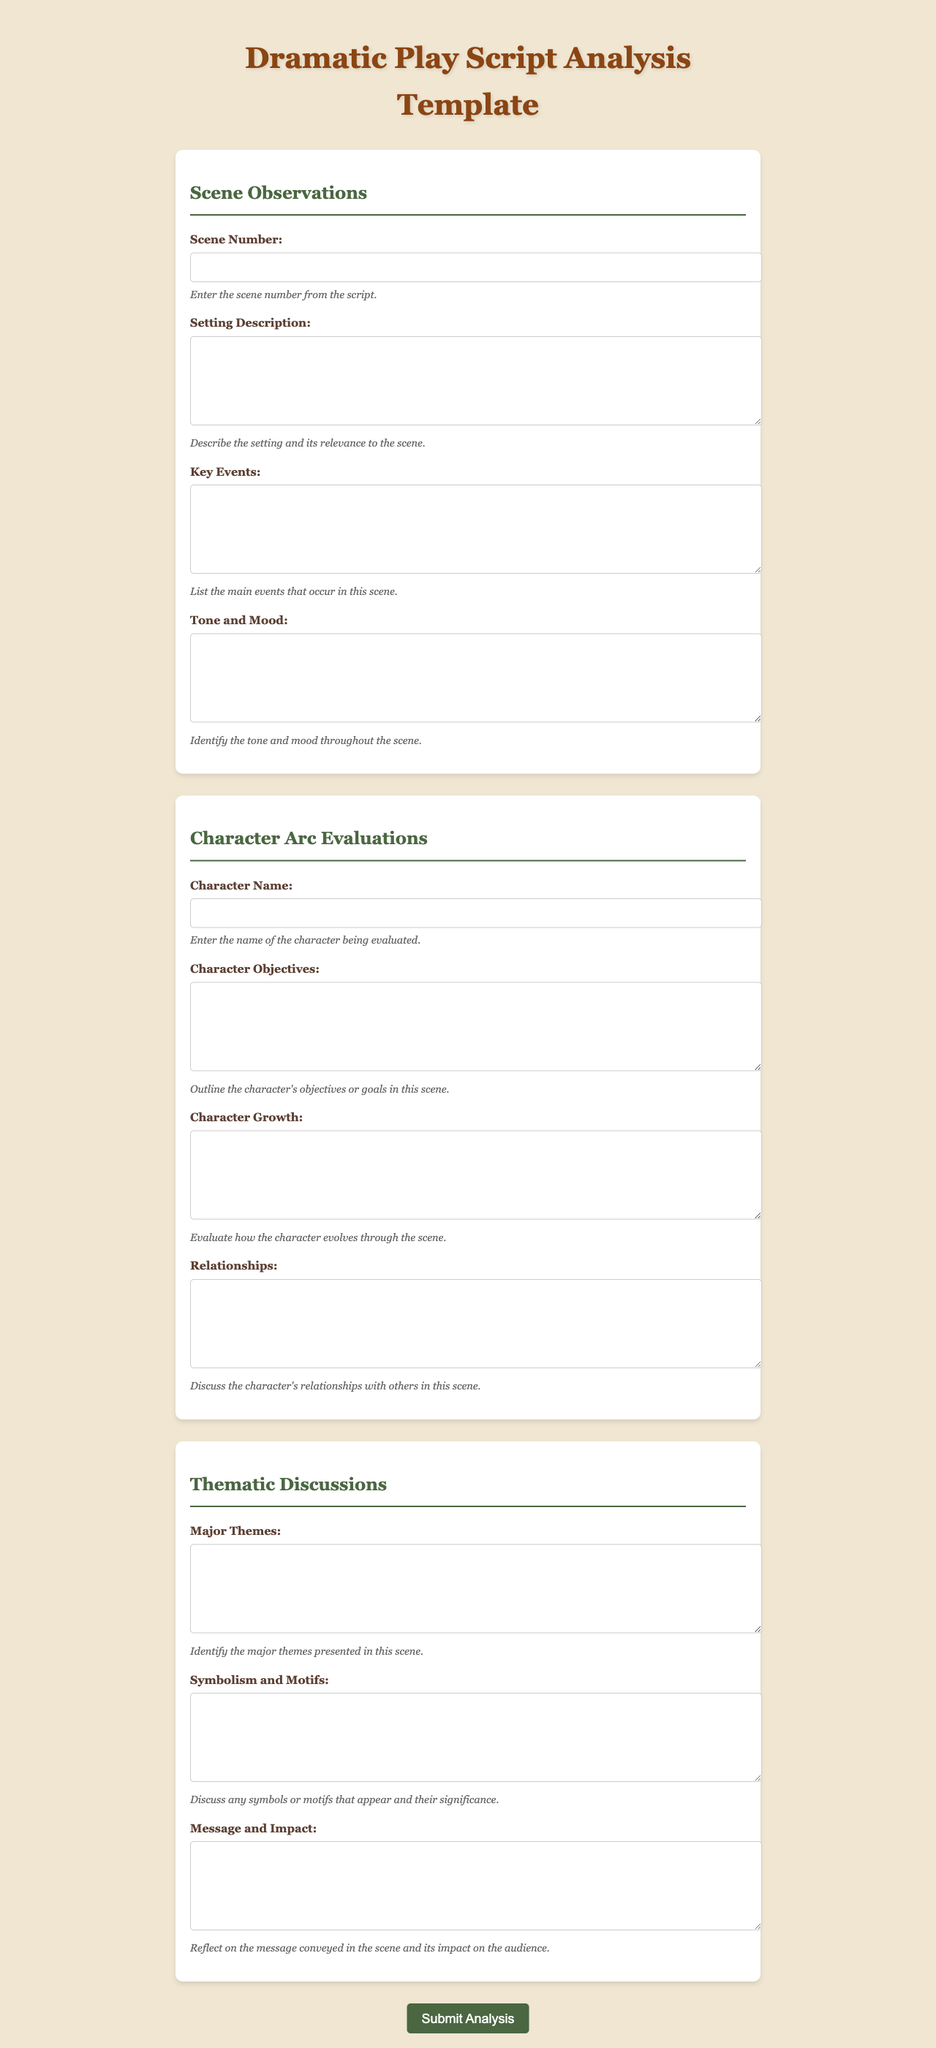What is the title of the document? The title of the document is stated at the top of the rendered form.
Answer: Dramatic Play Script Analysis Template How many sections are there in the form? The form has three distinct sections for analysis as identified by the headings.
Answer: 3 What is the label for the input related to character evaluation? The input for character evaluation requires the user's attention as indicated by its label.
Answer: Character Name What type of text does the 'Key Events' field expect? The field indicates what kind of response is expected from the user for key events in the scene.
Answer: Textarea What color is the button upon hover? The button changes color when hovered over, indicating an interactive feature.
Answer: #5c8152 Which section discusses the character's growth? The section where character evolution is evaluated is explicitly named in the document.
Answer: Character Arc Evaluations What is the purpose of the 'Setting Description' input? The 'Setting Description' field has a specific intention outlined to the user.
Answer: Describe the setting and its relevance to the scene What is the font family used in the document? The document's aesthetic includes a specified font for readability and style.
Answer: Georgia What is the purpose of the 'Message and Impact' field? This field is designated to reflect on what the scene conveys and its audience effect.
Answer: Reflect on the message conveyed in the scene and its impact on the audience 